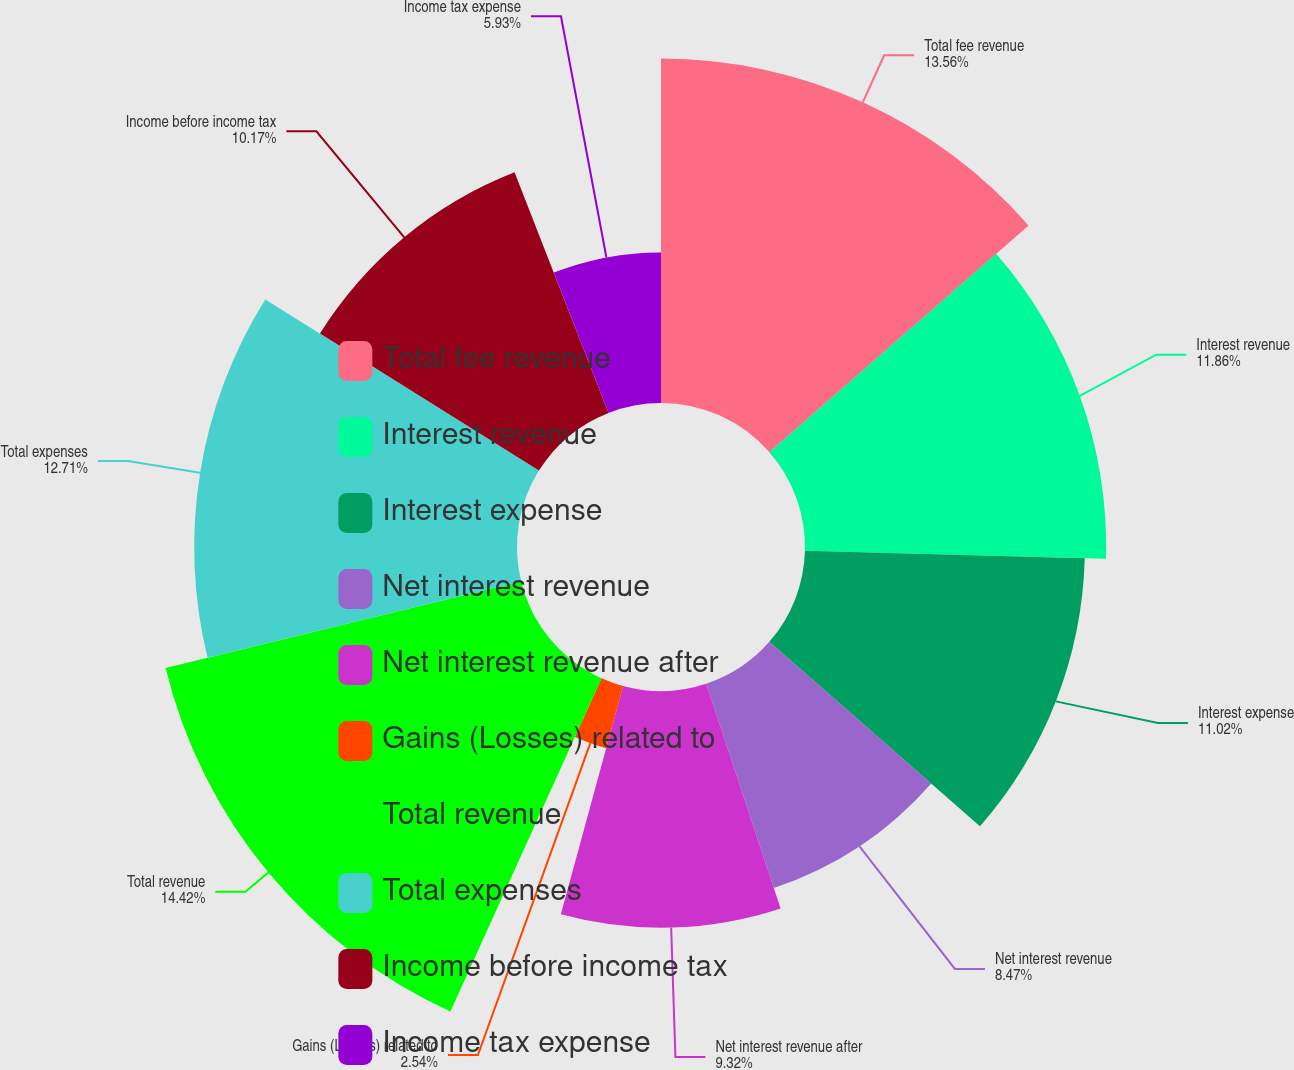Convert chart. <chart><loc_0><loc_0><loc_500><loc_500><pie_chart><fcel>Total fee revenue<fcel>Interest revenue<fcel>Interest expense<fcel>Net interest revenue<fcel>Net interest revenue after<fcel>Gains (Losses) related to<fcel>Total revenue<fcel>Total expenses<fcel>Income before income tax<fcel>Income tax expense<nl><fcel>13.56%<fcel>11.86%<fcel>11.02%<fcel>8.47%<fcel>9.32%<fcel>2.54%<fcel>14.41%<fcel>12.71%<fcel>10.17%<fcel>5.93%<nl></chart> 